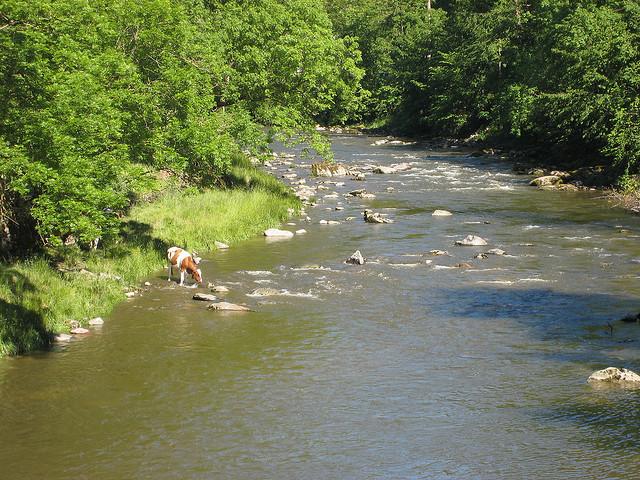Is this ocean?
Short answer required. No. Is there a bridge in this picture?
Answer briefly. No. What type of water body is this?
Be succinct. River. Is the man wearing a wetsuit?
Be succinct. No. Where is this?
Be succinct. River. Is anyone in the water?
Concise answer only. No. What is drinking the water?
Write a very short answer. Cow. 